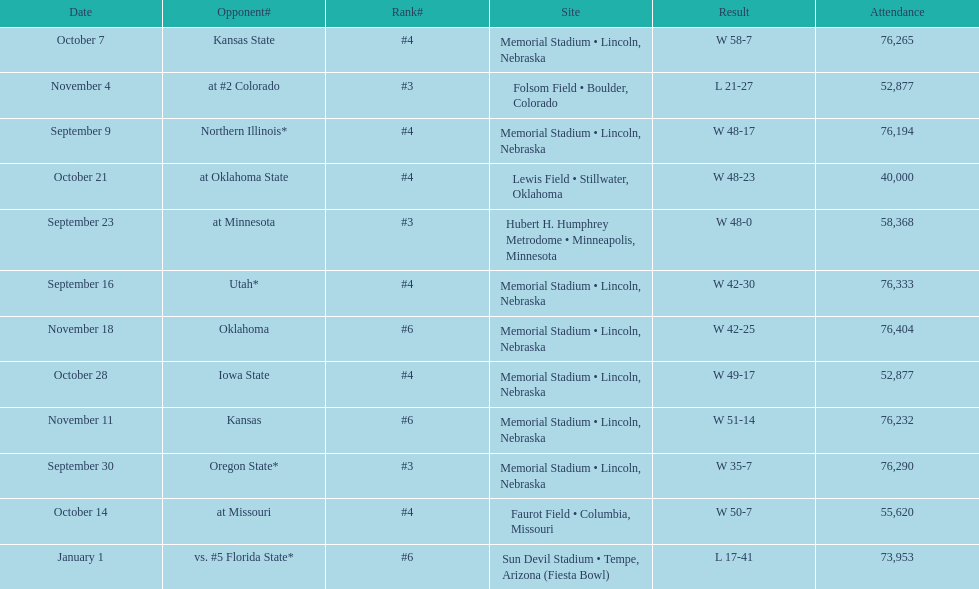How many games did they win by more than 7? 10. 